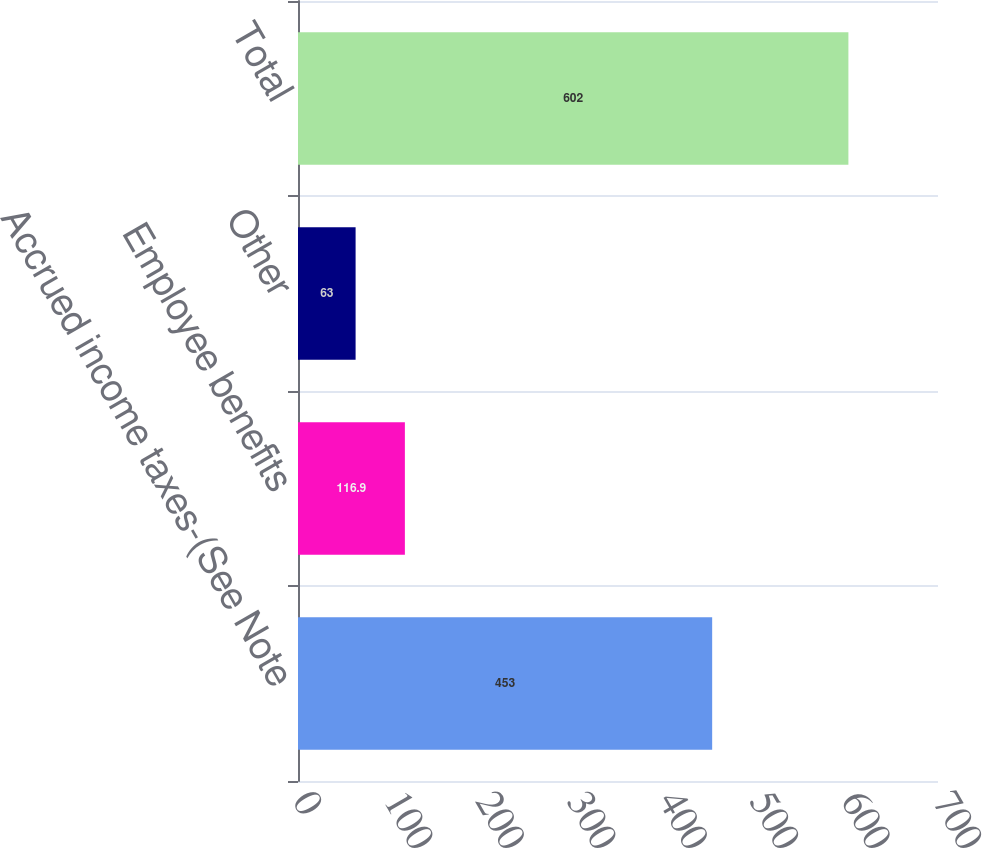Convert chart. <chart><loc_0><loc_0><loc_500><loc_500><bar_chart><fcel>Accrued income taxes-(See Note<fcel>Employee benefits<fcel>Other<fcel>Total<nl><fcel>453<fcel>116.9<fcel>63<fcel>602<nl></chart> 